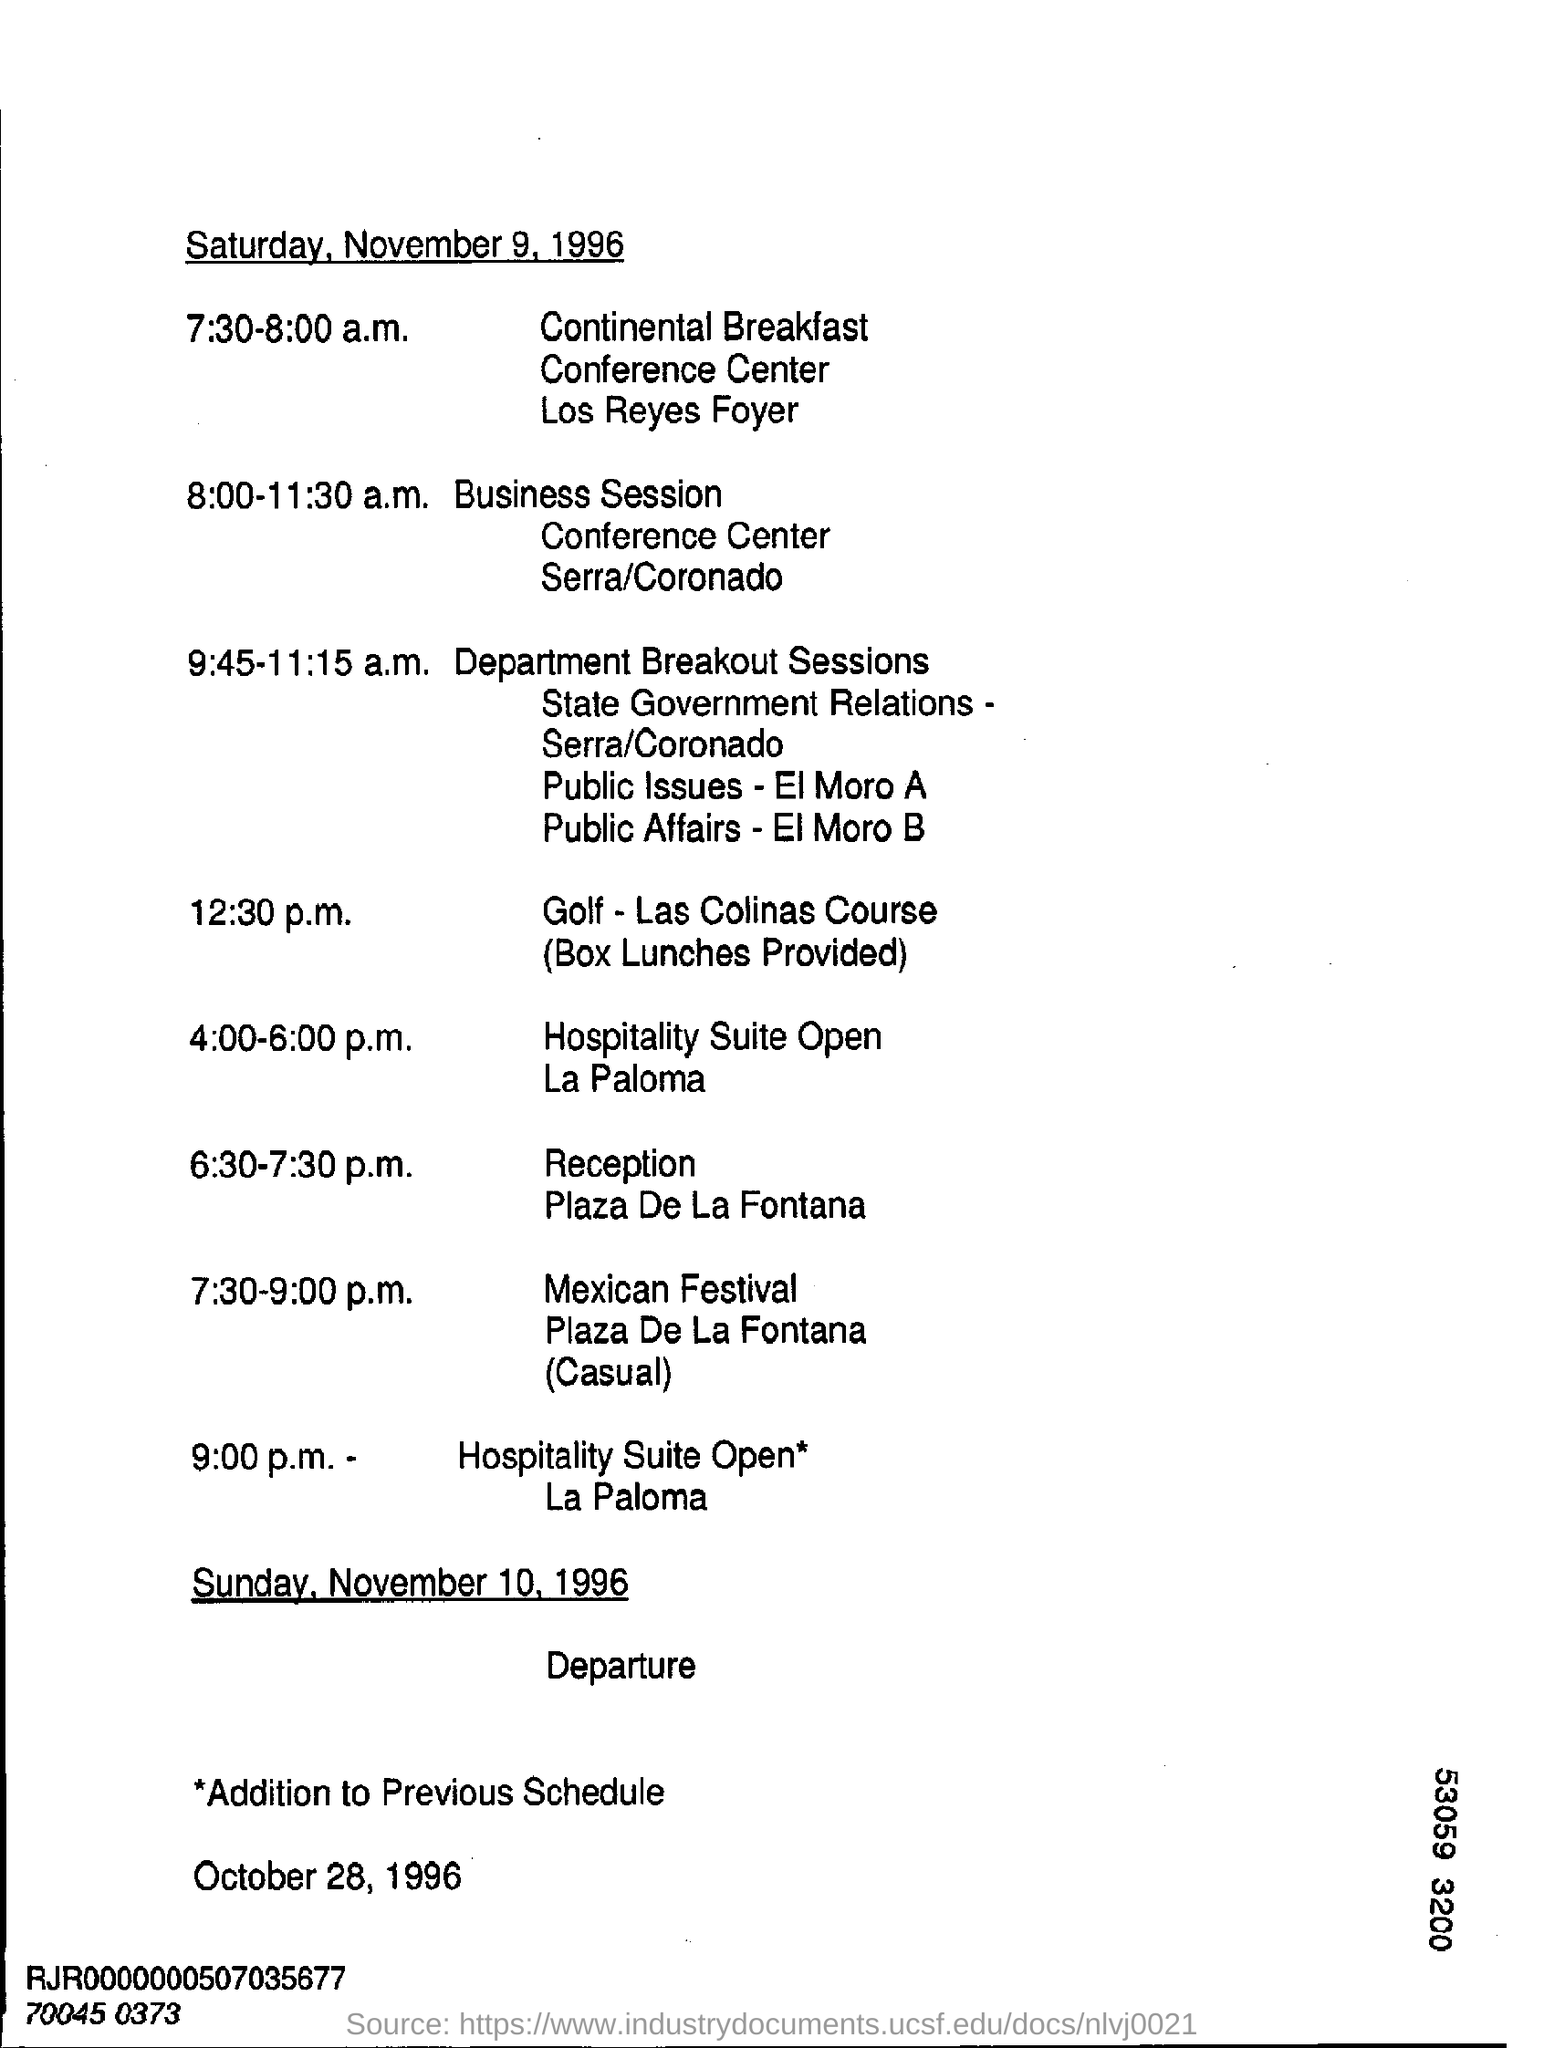Draw attention to some important aspects in this diagram. The date mentioned at the top of the document is November 9, 1996. The timing of reception is from 6:30 to 7:30 p.m. The scheduled timing for the Golf - Las Colinas Course is 12:30 p.m. The date mentioned at the bottom of the document is October 28, 1996. 